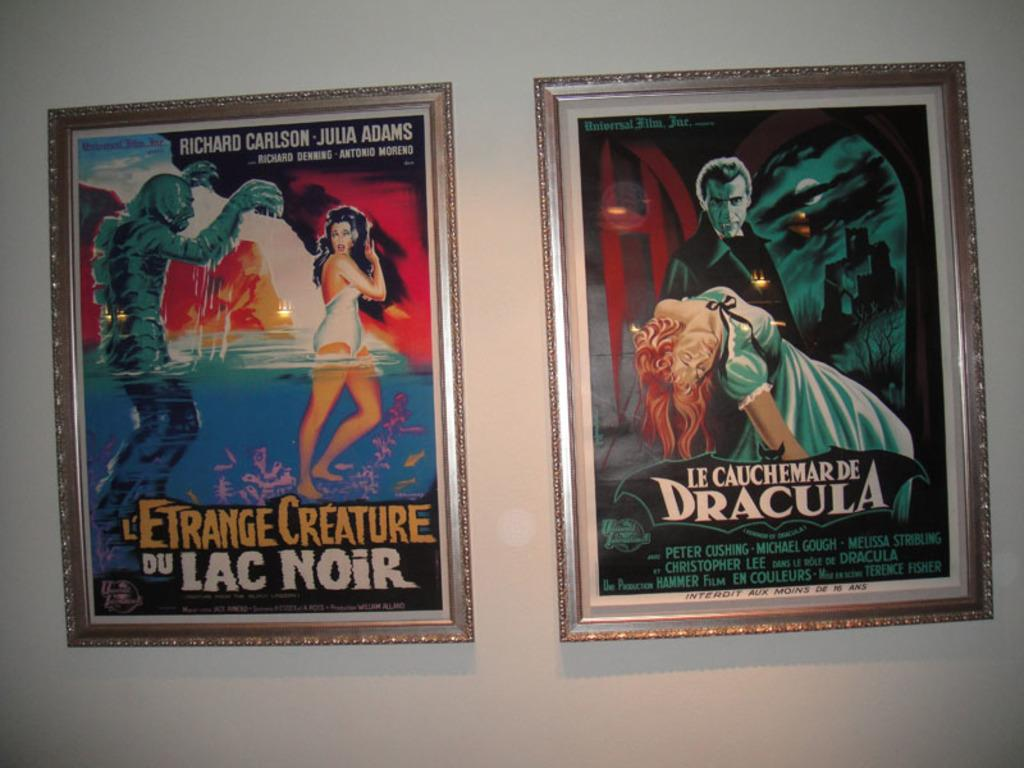<image>
Offer a succinct explanation of the picture presented. A poster of a movie by Richard Carlson is next to a Dracula movie. 